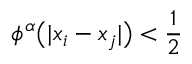<formula> <loc_0><loc_0><loc_500><loc_500>\phi ^ { \alpha } \left ( | x _ { i } - x _ { j } | \right ) < \frac { 1 } { 2 }</formula> 